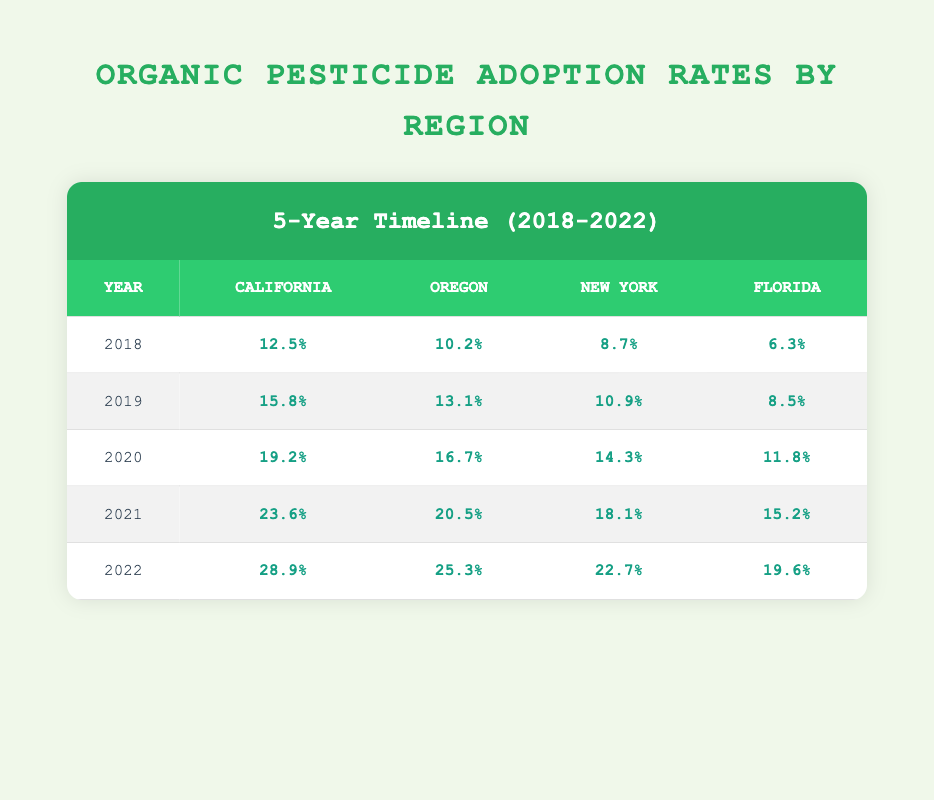What was the adoption rate of organic pesticides in California in 2019? The table shows that the adoption rate in California in 2019 is 15.8%.
Answer: 15.8% Which region had the lowest organic pesticide adoption rate in 2020? By comparing the adoption rates in 2020 for all regions, Florida had the lowest adoption rate at 11.8%.
Answer: Florida What was the increase in adoption rate for Oregon from 2021 to 2022? The adoption rate for Oregon in 2021 was 20.5%, and in 2022 it increased to 25.3%. The increase is calculated as 25.3% - 20.5% = 4.8%.
Answer: 4.8% Was there a year when New York's adoption rate fell compared to the previous year? Looking through the table, New York's adoption rate increased each year from 2018 to 2022. Therefore, there was no year where it fell.
Answer: No What is the average adoption rate across all regions for the year 2022? To calculate the average, add the adoption rates for all regions in 2022: (28.9 + 25.3 + 22.7 + 19.6) / 4 = 96.5 / 4 = 24.125%.
Answer: 24.125% How much did the adoption rate in California increase from 2018 to 2022? From the table, the adoption rate in California was 12.5% in 2018 and increased to 28.9% in 2022. The difference is 28.9% - 12.5% = 16.4%.
Answer: 16.4% In which year did Florida show the highest adoption rate? By examining the data for Florida, the highest adoption rate is in 2022, which is 19.6%.
Answer: 2022 What is the median adoption rate for Oregon over the five years? Arranging the adoption rates for Oregon (10.2, 13.1, 16.7, 20.5, 25.3), the middle value (median) is 16.7% since there are five values.
Answer: 16.7% 